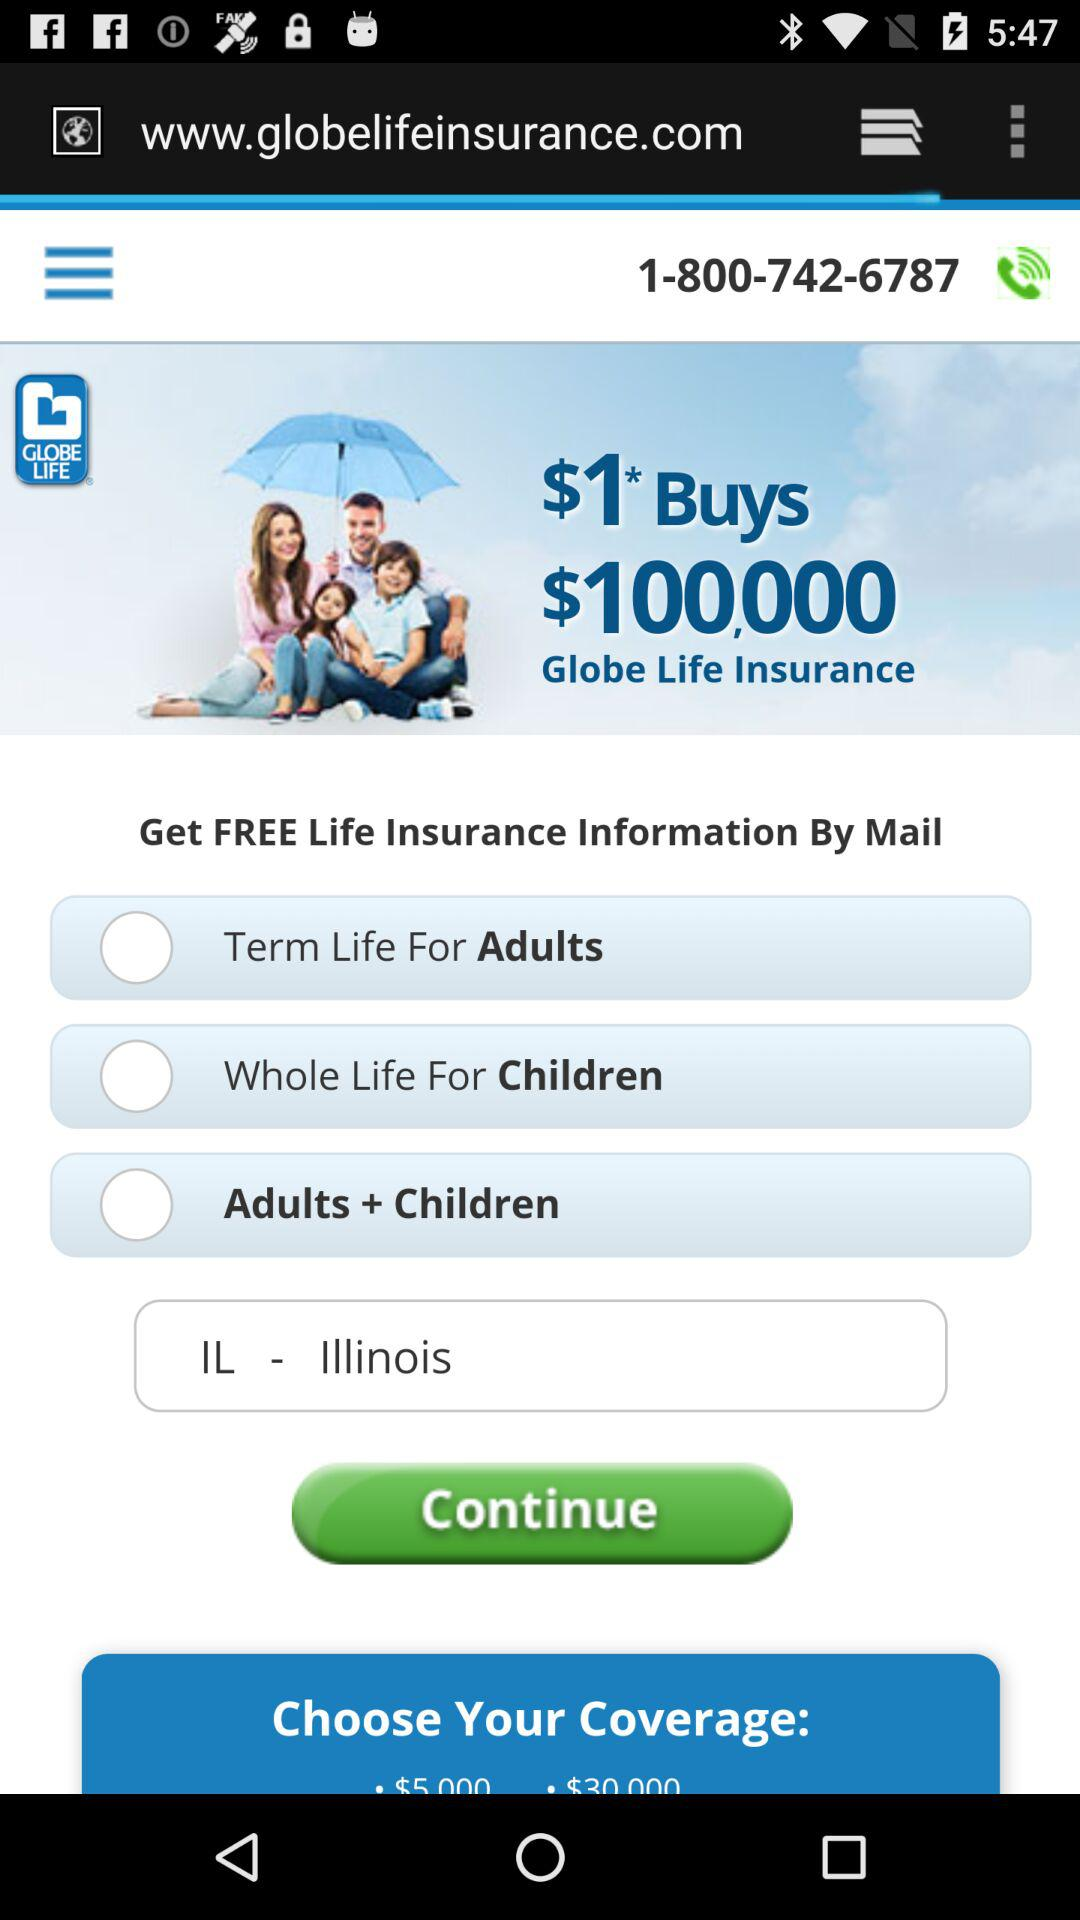How many coverage options are there? 3 